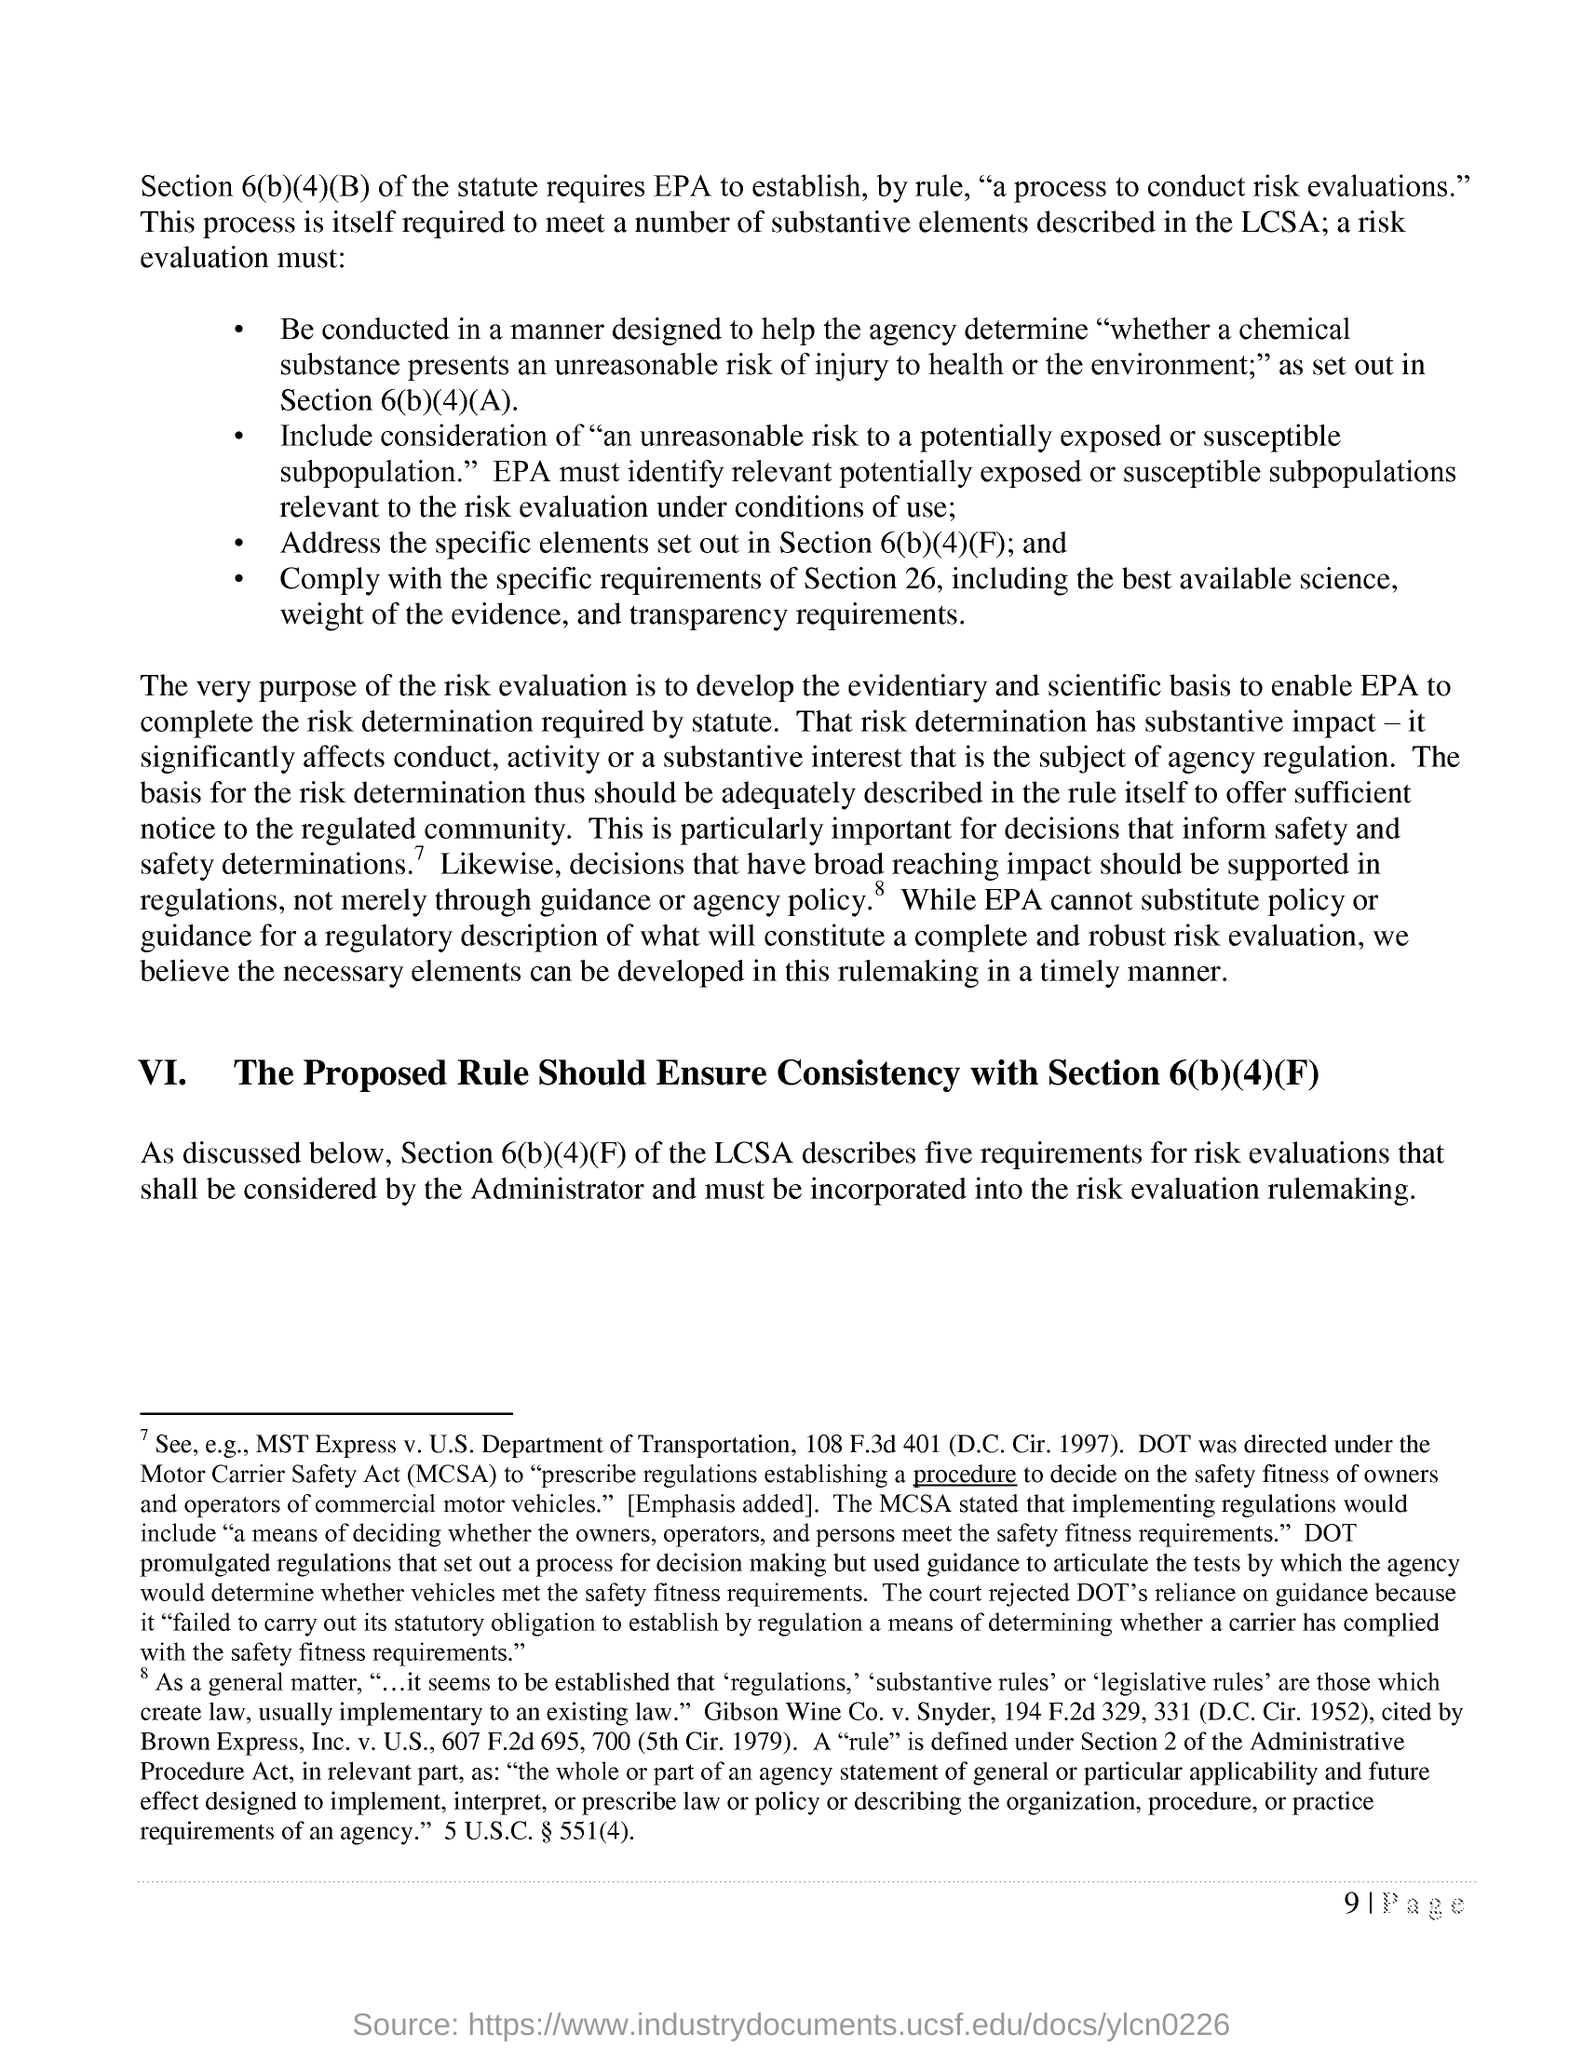Identify some key points in this picture. The full form of MCSA is "Motor Carrier Safety Act." This legislation is designed to improve the safety of commercial motor vehicles and the drivers who operate them. 